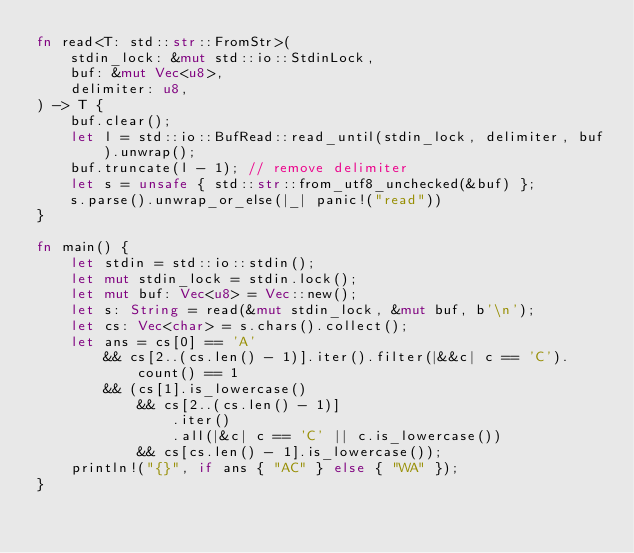<code> <loc_0><loc_0><loc_500><loc_500><_Rust_>fn read<T: std::str::FromStr>(
    stdin_lock: &mut std::io::StdinLock,
    buf: &mut Vec<u8>,
    delimiter: u8,
) -> T {
    buf.clear();
    let l = std::io::BufRead::read_until(stdin_lock, delimiter, buf).unwrap();
    buf.truncate(l - 1); // remove delimiter
    let s = unsafe { std::str::from_utf8_unchecked(&buf) };
    s.parse().unwrap_or_else(|_| panic!("read"))
}

fn main() {
    let stdin = std::io::stdin();
    let mut stdin_lock = stdin.lock();
    let mut buf: Vec<u8> = Vec::new();
    let s: String = read(&mut stdin_lock, &mut buf, b'\n');
    let cs: Vec<char> = s.chars().collect();
    let ans = cs[0] == 'A'
        && cs[2..(cs.len() - 1)].iter().filter(|&&c| c == 'C').count() == 1
        && (cs[1].is_lowercase()
            && cs[2..(cs.len() - 1)]
                .iter()
                .all(|&c| c == 'C' || c.is_lowercase())
            && cs[cs.len() - 1].is_lowercase());
    println!("{}", if ans { "AC" } else { "WA" });
}
</code> 